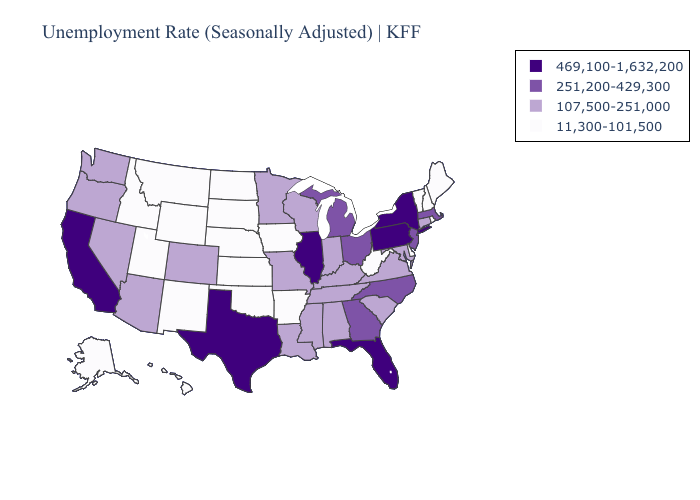What is the value of Tennessee?
Write a very short answer. 107,500-251,000. Does the first symbol in the legend represent the smallest category?
Keep it brief. No. Name the states that have a value in the range 469,100-1,632,200?
Keep it brief. California, Florida, Illinois, New York, Pennsylvania, Texas. What is the value of Iowa?
Write a very short answer. 11,300-101,500. Among the states that border Indiana , which have the highest value?
Concise answer only. Illinois. Name the states that have a value in the range 251,200-429,300?
Give a very brief answer. Georgia, Massachusetts, Michigan, New Jersey, North Carolina, Ohio. Is the legend a continuous bar?
Keep it brief. No. What is the lowest value in the Northeast?
Be succinct. 11,300-101,500. Does Illinois have the highest value in the MidWest?
Keep it brief. Yes. Which states hav the highest value in the MidWest?
Answer briefly. Illinois. Does the first symbol in the legend represent the smallest category?
Write a very short answer. No. Among the states that border Illinois , does Kentucky have the highest value?
Be succinct. Yes. Does Massachusetts have a higher value than California?
Quick response, please. No. What is the highest value in states that border Nebraska?
Keep it brief. 107,500-251,000. What is the lowest value in the USA?
Answer briefly. 11,300-101,500. 